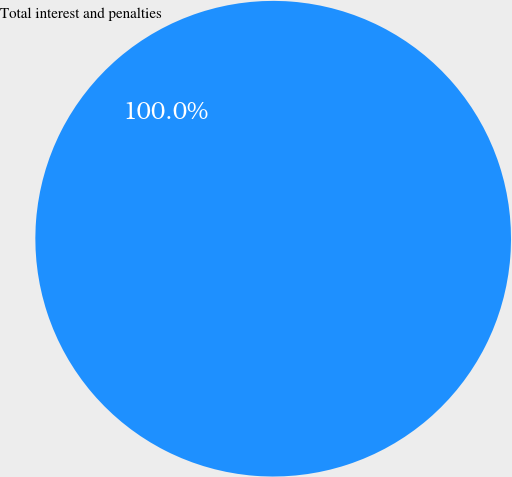Convert chart. <chart><loc_0><loc_0><loc_500><loc_500><pie_chart><fcel>Total interest and penalties<nl><fcel>100.0%<nl></chart> 